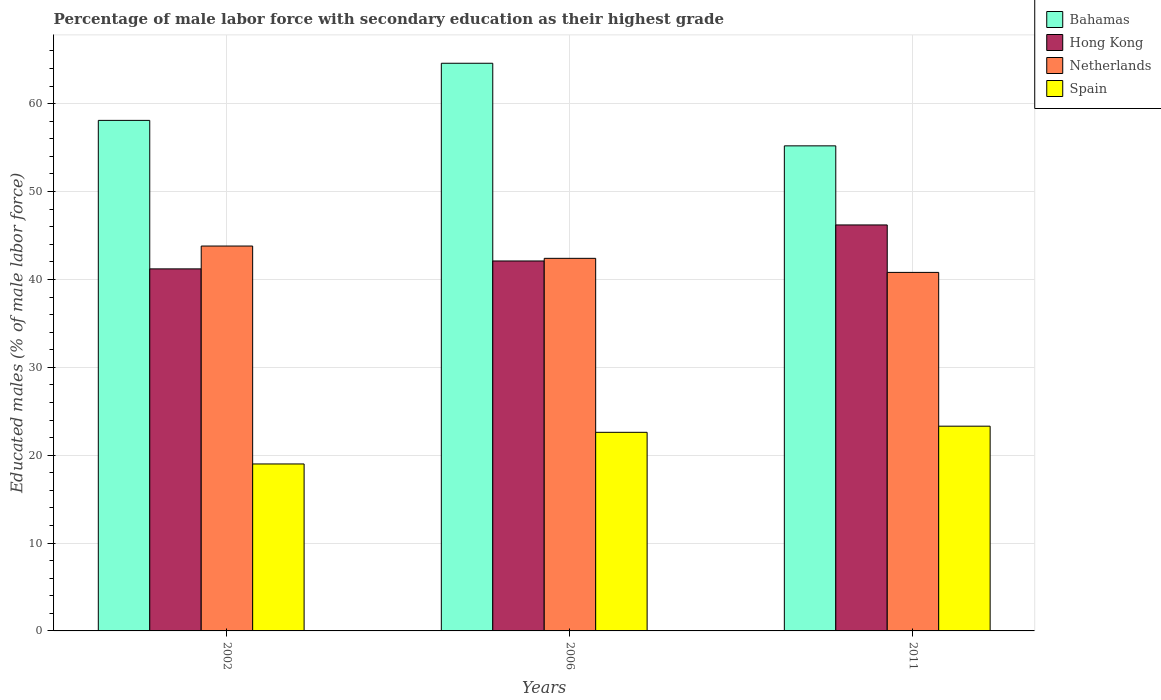How many groups of bars are there?
Provide a short and direct response. 3. Are the number of bars per tick equal to the number of legend labels?
Give a very brief answer. Yes. How many bars are there on the 1st tick from the left?
Your answer should be very brief. 4. What is the percentage of male labor force with secondary education in Bahamas in 2011?
Offer a terse response. 55.2. Across all years, what is the maximum percentage of male labor force with secondary education in Netherlands?
Give a very brief answer. 43.8. Across all years, what is the minimum percentage of male labor force with secondary education in Hong Kong?
Provide a succinct answer. 41.2. In which year was the percentage of male labor force with secondary education in Netherlands maximum?
Offer a very short reply. 2002. In which year was the percentage of male labor force with secondary education in Hong Kong minimum?
Your response must be concise. 2002. What is the total percentage of male labor force with secondary education in Hong Kong in the graph?
Make the answer very short. 129.5. What is the difference between the percentage of male labor force with secondary education in Spain in 2002 and that in 2006?
Your response must be concise. -3.6. What is the difference between the percentage of male labor force with secondary education in Bahamas in 2011 and the percentage of male labor force with secondary education in Hong Kong in 2006?
Keep it short and to the point. 13.1. What is the average percentage of male labor force with secondary education in Spain per year?
Ensure brevity in your answer.  21.63. In the year 2011, what is the difference between the percentage of male labor force with secondary education in Netherlands and percentage of male labor force with secondary education in Bahamas?
Make the answer very short. -14.4. In how many years, is the percentage of male labor force with secondary education in Netherlands greater than 22 %?
Offer a terse response. 3. What is the ratio of the percentage of male labor force with secondary education in Bahamas in 2006 to that in 2011?
Provide a succinct answer. 1.17. Is the difference between the percentage of male labor force with secondary education in Netherlands in 2006 and 2011 greater than the difference between the percentage of male labor force with secondary education in Bahamas in 2006 and 2011?
Provide a short and direct response. No. What is the difference between the highest and the second highest percentage of male labor force with secondary education in Bahamas?
Make the answer very short. 6.5. What is the difference between the highest and the lowest percentage of male labor force with secondary education in Hong Kong?
Provide a short and direct response. 5. Is the sum of the percentage of male labor force with secondary education in Hong Kong in 2002 and 2006 greater than the maximum percentage of male labor force with secondary education in Netherlands across all years?
Provide a succinct answer. Yes. What does the 2nd bar from the left in 2011 represents?
Ensure brevity in your answer.  Hong Kong. What does the 3rd bar from the right in 2002 represents?
Your answer should be compact. Hong Kong. What is the difference between two consecutive major ticks on the Y-axis?
Ensure brevity in your answer.  10. Does the graph contain any zero values?
Make the answer very short. No. Does the graph contain grids?
Your answer should be very brief. Yes. How are the legend labels stacked?
Give a very brief answer. Vertical. What is the title of the graph?
Provide a succinct answer. Percentage of male labor force with secondary education as their highest grade. What is the label or title of the X-axis?
Keep it short and to the point. Years. What is the label or title of the Y-axis?
Provide a short and direct response. Educated males (% of male labor force). What is the Educated males (% of male labor force) in Bahamas in 2002?
Your answer should be very brief. 58.1. What is the Educated males (% of male labor force) in Hong Kong in 2002?
Provide a short and direct response. 41.2. What is the Educated males (% of male labor force) in Netherlands in 2002?
Provide a short and direct response. 43.8. What is the Educated males (% of male labor force) of Spain in 2002?
Offer a very short reply. 19. What is the Educated males (% of male labor force) in Bahamas in 2006?
Offer a terse response. 64.6. What is the Educated males (% of male labor force) of Hong Kong in 2006?
Offer a very short reply. 42.1. What is the Educated males (% of male labor force) in Netherlands in 2006?
Give a very brief answer. 42.4. What is the Educated males (% of male labor force) of Spain in 2006?
Your answer should be very brief. 22.6. What is the Educated males (% of male labor force) in Bahamas in 2011?
Your answer should be compact. 55.2. What is the Educated males (% of male labor force) of Hong Kong in 2011?
Your response must be concise. 46.2. What is the Educated males (% of male labor force) in Netherlands in 2011?
Offer a terse response. 40.8. What is the Educated males (% of male labor force) in Spain in 2011?
Offer a terse response. 23.3. Across all years, what is the maximum Educated males (% of male labor force) in Bahamas?
Give a very brief answer. 64.6. Across all years, what is the maximum Educated males (% of male labor force) in Hong Kong?
Provide a succinct answer. 46.2. Across all years, what is the maximum Educated males (% of male labor force) in Netherlands?
Ensure brevity in your answer.  43.8. Across all years, what is the maximum Educated males (% of male labor force) of Spain?
Your answer should be compact. 23.3. Across all years, what is the minimum Educated males (% of male labor force) of Bahamas?
Keep it short and to the point. 55.2. Across all years, what is the minimum Educated males (% of male labor force) of Hong Kong?
Offer a very short reply. 41.2. Across all years, what is the minimum Educated males (% of male labor force) in Netherlands?
Offer a very short reply. 40.8. What is the total Educated males (% of male labor force) in Bahamas in the graph?
Provide a succinct answer. 177.9. What is the total Educated males (% of male labor force) in Hong Kong in the graph?
Your answer should be very brief. 129.5. What is the total Educated males (% of male labor force) of Netherlands in the graph?
Make the answer very short. 127. What is the total Educated males (% of male labor force) in Spain in the graph?
Keep it short and to the point. 64.9. What is the difference between the Educated males (% of male labor force) of Bahamas in 2002 and that in 2006?
Your answer should be very brief. -6.5. What is the difference between the Educated males (% of male labor force) of Netherlands in 2002 and that in 2006?
Your answer should be very brief. 1.4. What is the difference between the Educated males (% of male labor force) of Hong Kong in 2002 and that in 2011?
Offer a terse response. -5. What is the difference between the Educated males (% of male labor force) of Spain in 2002 and that in 2011?
Offer a terse response. -4.3. What is the difference between the Educated males (% of male labor force) of Bahamas in 2006 and that in 2011?
Provide a succinct answer. 9.4. What is the difference between the Educated males (% of male labor force) of Hong Kong in 2006 and that in 2011?
Your answer should be very brief. -4.1. What is the difference between the Educated males (% of male labor force) of Netherlands in 2006 and that in 2011?
Your answer should be compact. 1.6. What is the difference between the Educated males (% of male labor force) of Bahamas in 2002 and the Educated males (% of male labor force) of Spain in 2006?
Make the answer very short. 35.5. What is the difference between the Educated males (% of male labor force) in Hong Kong in 2002 and the Educated males (% of male labor force) in Spain in 2006?
Provide a succinct answer. 18.6. What is the difference between the Educated males (% of male labor force) in Netherlands in 2002 and the Educated males (% of male labor force) in Spain in 2006?
Ensure brevity in your answer.  21.2. What is the difference between the Educated males (% of male labor force) in Bahamas in 2002 and the Educated males (% of male labor force) in Hong Kong in 2011?
Offer a terse response. 11.9. What is the difference between the Educated males (% of male labor force) in Bahamas in 2002 and the Educated males (% of male labor force) in Spain in 2011?
Your answer should be very brief. 34.8. What is the difference between the Educated males (% of male labor force) in Hong Kong in 2002 and the Educated males (% of male labor force) in Netherlands in 2011?
Ensure brevity in your answer.  0.4. What is the difference between the Educated males (% of male labor force) of Hong Kong in 2002 and the Educated males (% of male labor force) of Spain in 2011?
Your answer should be very brief. 17.9. What is the difference between the Educated males (% of male labor force) of Bahamas in 2006 and the Educated males (% of male labor force) of Hong Kong in 2011?
Your response must be concise. 18.4. What is the difference between the Educated males (% of male labor force) of Bahamas in 2006 and the Educated males (% of male labor force) of Netherlands in 2011?
Ensure brevity in your answer.  23.8. What is the difference between the Educated males (% of male labor force) in Bahamas in 2006 and the Educated males (% of male labor force) in Spain in 2011?
Your response must be concise. 41.3. What is the difference between the Educated males (% of male labor force) in Hong Kong in 2006 and the Educated males (% of male labor force) in Netherlands in 2011?
Give a very brief answer. 1.3. What is the difference between the Educated males (% of male labor force) of Hong Kong in 2006 and the Educated males (% of male labor force) of Spain in 2011?
Keep it short and to the point. 18.8. What is the average Educated males (% of male labor force) in Bahamas per year?
Offer a terse response. 59.3. What is the average Educated males (% of male labor force) in Hong Kong per year?
Make the answer very short. 43.17. What is the average Educated males (% of male labor force) of Netherlands per year?
Provide a succinct answer. 42.33. What is the average Educated males (% of male labor force) of Spain per year?
Your answer should be compact. 21.63. In the year 2002, what is the difference between the Educated males (% of male labor force) of Bahamas and Educated males (% of male labor force) of Hong Kong?
Provide a short and direct response. 16.9. In the year 2002, what is the difference between the Educated males (% of male labor force) of Bahamas and Educated males (% of male labor force) of Netherlands?
Your answer should be compact. 14.3. In the year 2002, what is the difference between the Educated males (% of male labor force) of Bahamas and Educated males (% of male labor force) of Spain?
Your answer should be very brief. 39.1. In the year 2002, what is the difference between the Educated males (% of male labor force) of Hong Kong and Educated males (% of male labor force) of Netherlands?
Your answer should be compact. -2.6. In the year 2002, what is the difference between the Educated males (% of male labor force) of Netherlands and Educated males (% of male labor force) of Spain?
Your answer should be compact. 24.8. In the year 2006, what is the difference between the Educated males (% of male labor force) in Bahamas and Educated males (% of male labor force) in Hong Kong?
Offer a terse response. 22.5. In the year 2006, what is the difference between the Educated males (% of male labor force) of Bahamas and Educated males (% of male labor force) of Spain?
Your answer should be very brief. 42. In the year 2006, what is the difference between the Educated males (% of male labor force) of Hong Kong and Educated males (% of male labor force) of Netherlands?
Ensure brevity in your answer.  -0.3. In the year 2006, what is the difference between the Educated males (% of male labor force) in Netherlands and Educated males (% of male labor force) in Spain?
Make the answer very short. 19.8. In the year 2011, what is the difference between the Educated males (% of male labor force) of Bahamas and Educated males (% of male labor force) of Hong Kong?
Your response must be concise. 9. In the year 2011, what is the difference between the Educated males (% of male labor force) of Bahamas and Educated males (% of male labor force) of Spain?
Your response must be concise. 31.9. In the year 2011, what is the difference between the Educated males (% of male labor force) in Hong Kong and Educated males (% of male labor force) in Spain?
Make the answer very short. 22.9. In the year 2011, what is the difference between the Educated males (% of male labor force) in Netherlands and Educated males (% of male labor force) in Spain?
Offer a very short reply. 17.5. What is the ratio of the Educated males (% of male labor force) in Bahamas in 2002 to that in 2006?
Your answer should be very brief. 0.9. What is the ratio of the Educated males (% of male labor force) of Hong Kong in 2002 to that in 2006?
Make the answer very short. 0.98. What is the ratio of the Educated males (% of male labor force) in Netherlands in 2002 to that in 2006?
Your response must be concise. 1.03. What is the ratio of the Educated males (% of male labor force) of Spain in 2002 to that in 2006?
Your answer should be compact. 0.84. What is the ratio of the Educated males (% of male labor force) in Bahamas in 2002 to that in 2011?
Provide a short and direct response. 1.05. What is the ratio of the Educated males (% of male labor force) of Hong Kong in 2002 to that in 2011?
Offer a very short reply. 0.89. What is the ratio of the Educated males (% of male labor force) in Netherlands in 2002 to that in 2011?
Offer a terse response. 1.07. What is the ratio of the Educated males (% of male labor force) in Spain in 2002 to that in 2011?
Your answer should be very brief. 0.82. What is the ratio of the Educated males (% of male labor force) in Bahamas in 2006 to that in 2011?
Your answer should be compact. 1.17. What is the ratio of the Educated males (% of male labor force) of Hong Kong in 2006 to that in 2011?
Give a very brief answer. 0.91. What is the ratio of the Educated males (% of male labor force) in Netherlands in 2006 to that in 2011?
Keep it short and to the point. 1.04. What is the difference between the highest and the second highest Educated males (% of male labor force) of Bahamas?
Provide a succinct answer. 6.5. What is the difference between the highest and the second highest Educated males (% of male labor force) of Hong Kong?
Your response must be concise. 4.1. What is the difference between the highest and the second highest Educated males (% of male labor force) in Netherlands?
Your answer should be very brief. 1.4. What is the difference between the highest and the second highest Educated males (% of male labor force) in Spain?
Your response must be concise. 0.7. What is the difference between the highest and the lowest Educated males (% of male labor force) of Netherlands?
Make the answer very short. 3. 